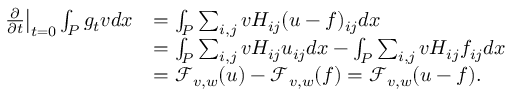Convert formula to latex. <formula><loc_0><loc_0><loc_500><loc_500>\begin{array} { r l } { \frac { \partial } { \partial t } \right | _ { t = 0 } \int _ { P } g _ { t } v d x } & { = \int _ { P } \sum _ { i , j } v H _ { i j } ( u - f ) _ { i j } d x } \\ & { = \int _ { P } \sum _ { i , j } v H _ { i j } u _ { i j } d x - \int _ { P } \sum _ { i , j } v H _ { i j } f _ { i j } d x } \\ & { = \mathcal { F } _ { v , w } ( u ) - \mathcal { F } _ { v , w } ( f ) = \mathcal { F } _ { v , w } ( u - f ) . } \end{array}</formula> 